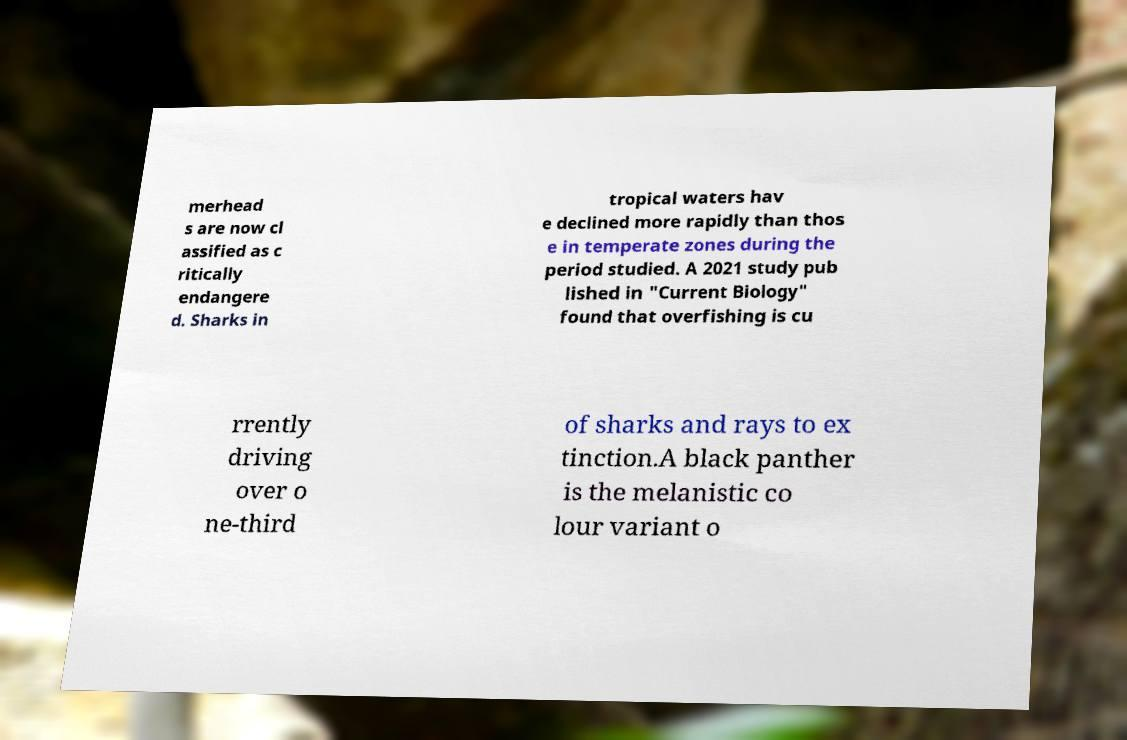Please read and relay the text visible in this image. What does it say? merhead s are now cl assified as c ritically endangere d. Sharks in tropical waters hav e declined more rapidly than thos e in temperate zones during the period studied. A 2021 study pub lished in "Current Biology" found that overfishing is cu rrently driving over o ne-third of sharks and rays to ex tinction.A black panther is the melanistic co lour variant o 